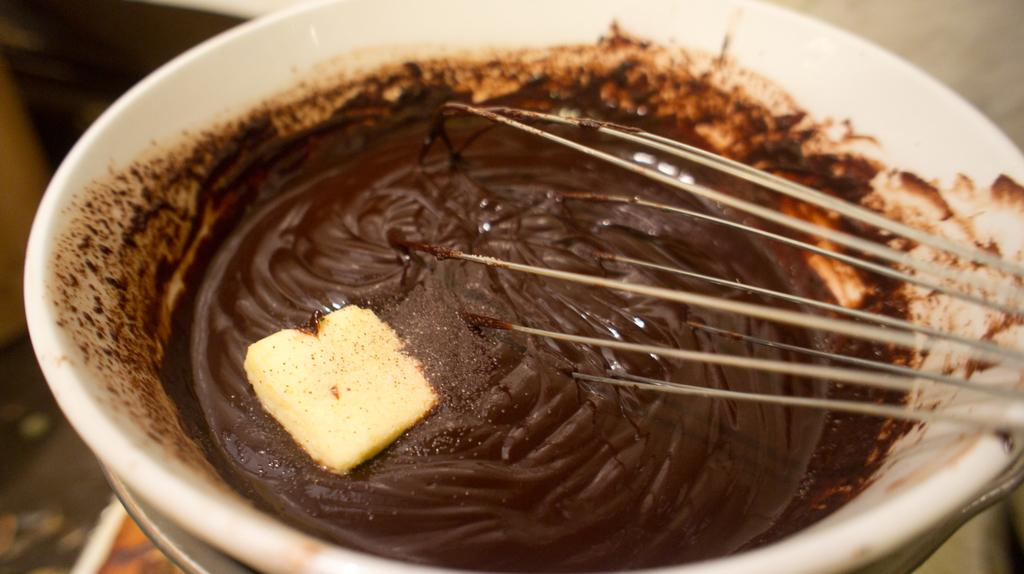What is in the bowl that is visible in the image? There is melted chocolate in the bowl. What object is also present in the bowl? There is an egg beater in the bowl. How would you describe the background of the image? The background of the image is blurred. Where is the sugar placed in the image? There is no sugar present in the image. What type of rat can be seen interacting with the egg beater in the image? There is no rat present in the image; it only features melted chocolate and an egg beater in a bowl. 